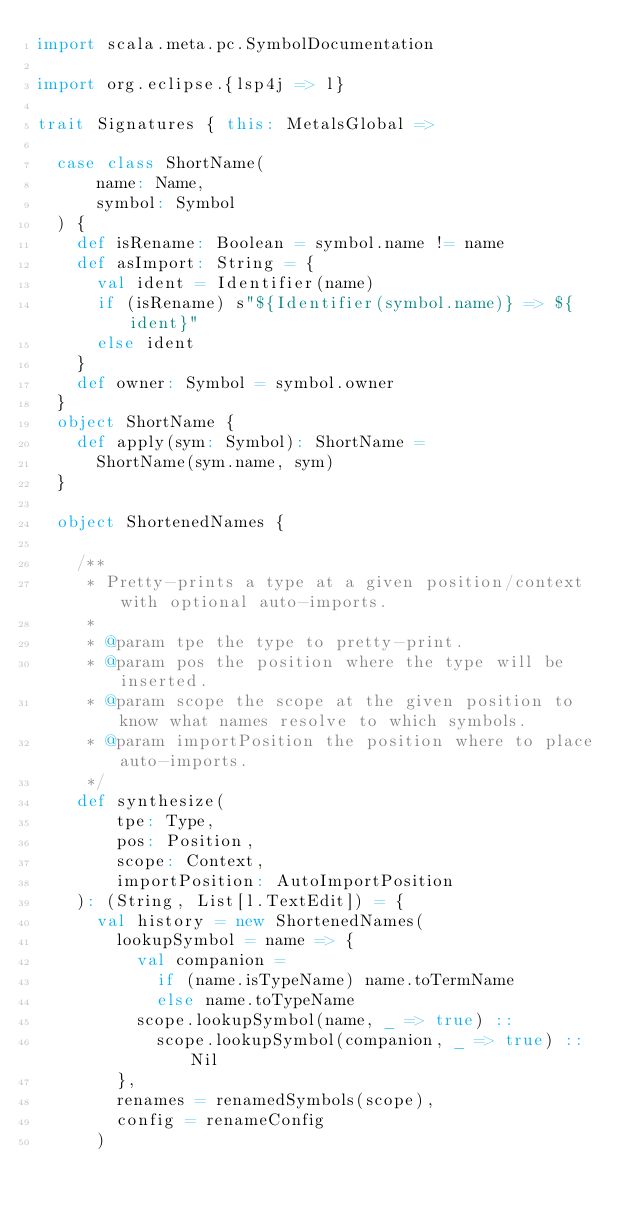<code> <loc_0><loc_0><loc_500><loc_500><_Scala_>import scala.meta.pc.SymbolDocumentation

import org.eclipse.{lsp4j => l}

trait Signatures { this: MetalsGlobal =>

  case class ShortName(
      name: Name,
      symbol: Symbol
  ) {
    def isRename: Boolean = symbol.name != name
    def asImport: String = {
      val ident = Identifier(name)
      if (isRename) s"${Identifier(symbol.name)} => ${ident}"
      else ident
    }
    def owner: Symbol = symbol.owner
  }
  object ShortName {
    def apply(sym: Symbol): ShortName =
      ShortName(sym.name, sym)
  }

  object ShortenedNames {

    /**
     * Pretty-prints a type at a given position/context with optional auto-imports.
     *
     * @param tpe the type to pretty-print.
     * @param pos the position where the type will be inserted.
     * @param scope the scope at the given position to know what names resolve to which symbols.
     * @param importPosition the position where to place auto-imports.
     */
    def synthesize(
        tpe: Type,
        pos: Position,
        scope: Context,
        importPosition: AutoImportPosition
    ): (String, List[l.TextEdit]) = {
      val history = new ShortenedNames(
        lookupSymbol = name => {
          val companion =
            if (name.isTypeName) name.toTermName
            else name.toTypeName
          scope.lookupSymbol(name, _ => true) ::
            scope.lookupSymbol(companion, _ => true) :: Nil
        },
        renames = renamedSymbols(scope),
        config = renameConfig
      )</code> 